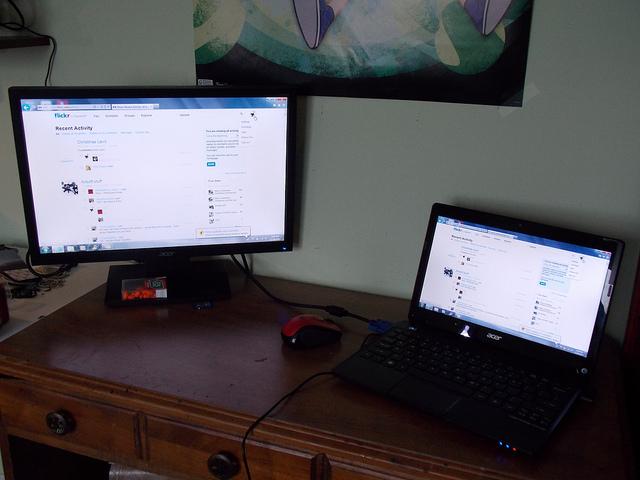Why doesn't the larger screen have a keyboard?
Write a very short answer. Unsure. Are the computer screen projecting the same image?
Write a very short answer. Yes. Is the wood behind the computer unfinished?
Be succinct. No. What is the material of the desk?
Answer briefly. Wood. 